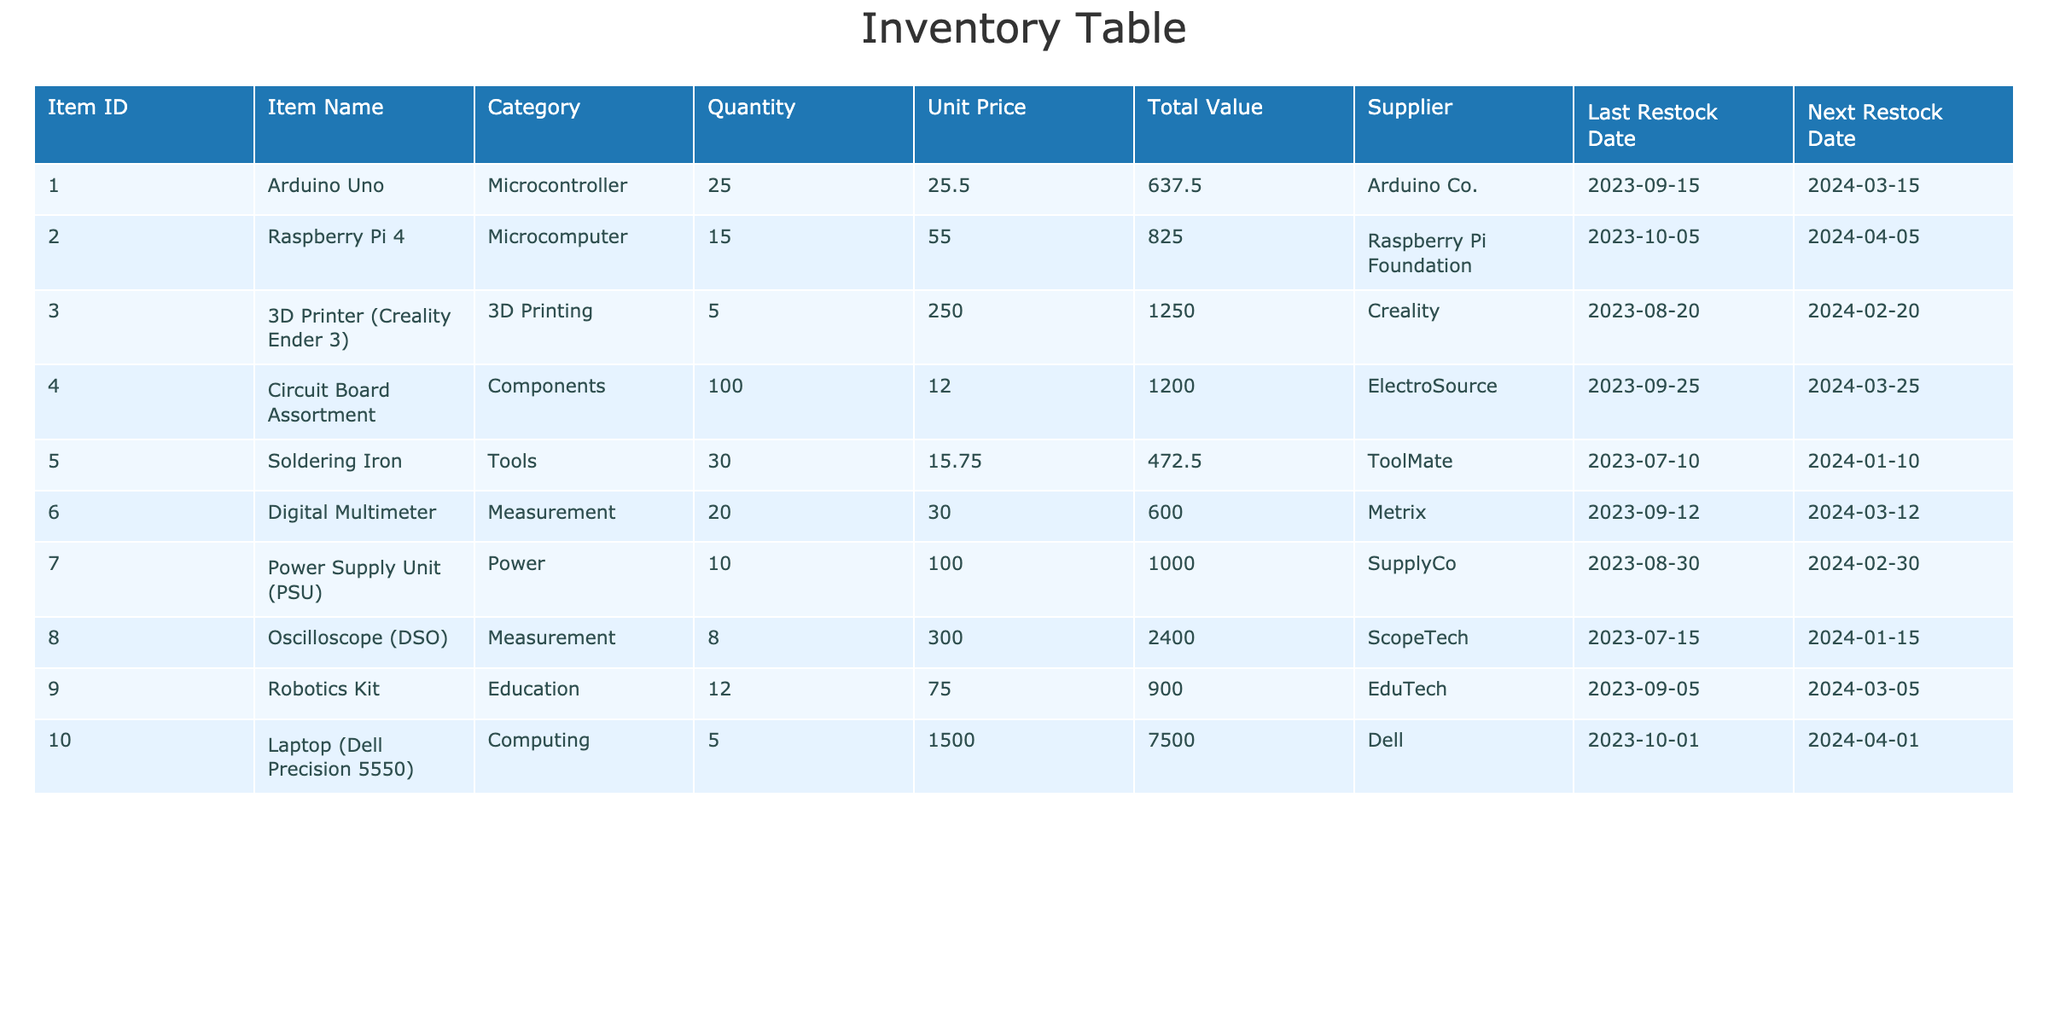What is the total stock quantity of all items? To find the total stock quantity, I will sum the quantities of each item listed: 25 (Arduino Uno) + 15 (Raspberry Pi 4) + 5 (3D Printer) + 100 (Circuit Board Assortment) + 30 (Soldering Iron) + 20 (Digital Multimeter) + 10 (Power Supply Unit) + 8 (Oscilloscope) + 12 (Robotics Kit) + 5 (Laptop) = 225.
Answer: 225 How many items are listed under the 'Measurement' category? Referring to the category column, I observe that there are two items under 'Measurement': Digital Multimeter and Oscilloscope. Therefore, the count is 2.
Answer: 2 What is the total value of items from 'Components' category? I will check the items in the 'Components' category, which only has the Circuit Board Assortment with a total value of 1200. Since there are no other items in this category, the total value is 1200.
Answer: 1200 Which supplier provides the highest total value of stocked items? I need to evaluate the total value provided by each supplier: Arduino Co. (637.50), Raspberry Pi Foundation (825.00), Creality (1250.00), ElectroSource (1200.00), ToolMate (472.50), Metrix (600.00), SupplyCo (1000.00), ScopeTech (2400.00), EduTech (900.00), and Dell (7500.00). Dell has the highest total value at 7500.
Answer: Dell Is the '3D Printer (Creality Ender 3)' due for restock before 'Raspberry Pi 4'? The last restock date for the 3D Printer is 2024-02-20 and for the Raspberry Pi 4, it is 2024-04-05. Since February is before April, the 3D Printer is due for restock before the Raspberry Pi 4.
Answer: Yes What is the average unit price of all items in the inventory? First, I will sum the unit prices: 25.50 (Arduino Uno) + 55.00 (Raspberry Pi 4) + 250.00 (3D Printer) + 12.00 (Circuit Board Assortment) + 15.75 (Soldering Iron) + 30.00 (Digital Multimeter) + 100.00 (Power Supply) + 300.00 (Oscilloscope) + 75.00 (Robotics Kit) + 1500.00 (Laptop) = 2018.25. Then, divide by the total number of items (10), resulting in an average unit price of 201.83.
Answer: 201.83 Which item has the least quantity in stock? By reviewing the Quantity column, I see the 3D Printer has the least quantity at 5.
Answer: 3D Printer (Creality Ender 3) Are there more items available for restock in March than in January? The items with restock dates in March include: Arduino Uno, Circuit Board Assortment, Digital Multimeter, and Robotics Kit, totaling 4 items. In January, the only item due for restock is the Soldering Iron. Hence, there are more items due for restock in March.
Answer: Yes 